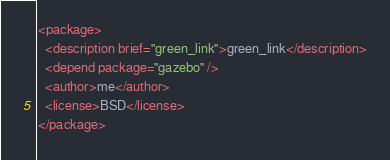Convert code to text. <code><loc_0><loc_0><loc_500><loc_500><_XML_><package>
  <description brief="green_link">green_link</description>
  <depend package="gazebo" />
  <author>me</author>
  <license>BSD</license>
</package></code> 